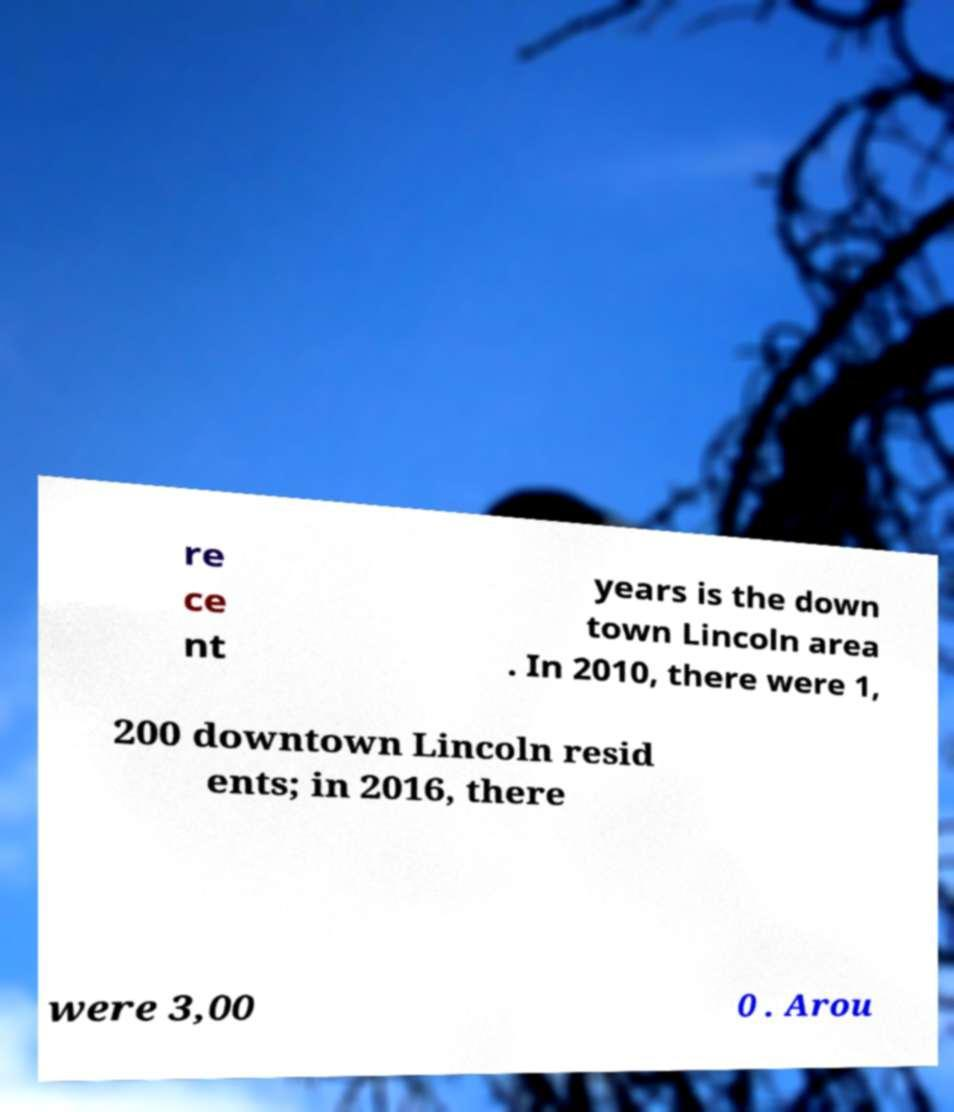Please read and relay the text visible in this image. What does it say? re ce nt years is the down town Lincoln area . In 2010, there were 1, 200 downtown Lincoln resid ents; in 2016, there were 3,00 0 . Arou 